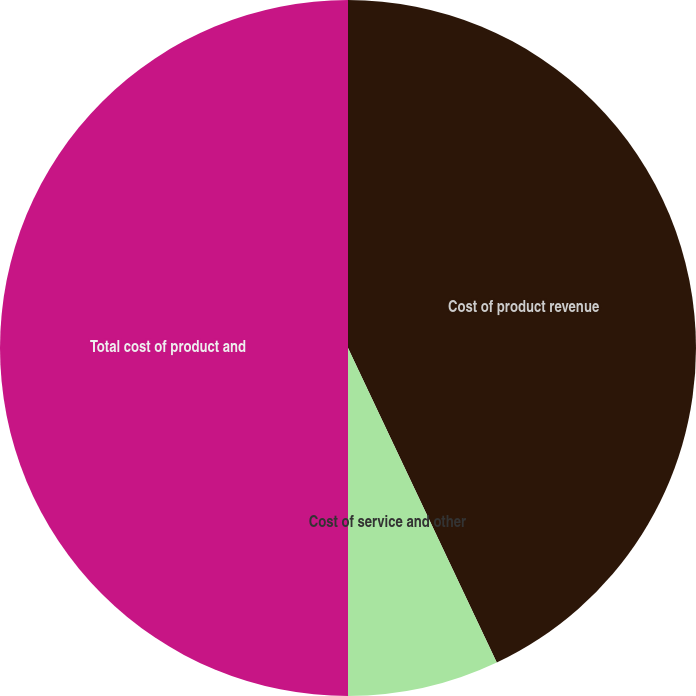Convert chart to OTSL. <chart><loc_0><loc_0><loc_500><loc_500><pie_chart><fcel>Cost of product revenue<fcel>Cost of service and other<fcel>Total cost of product and<nl><fcel>42.97%<fcel>7.03%<fcel>50.0%<nl></chart> 